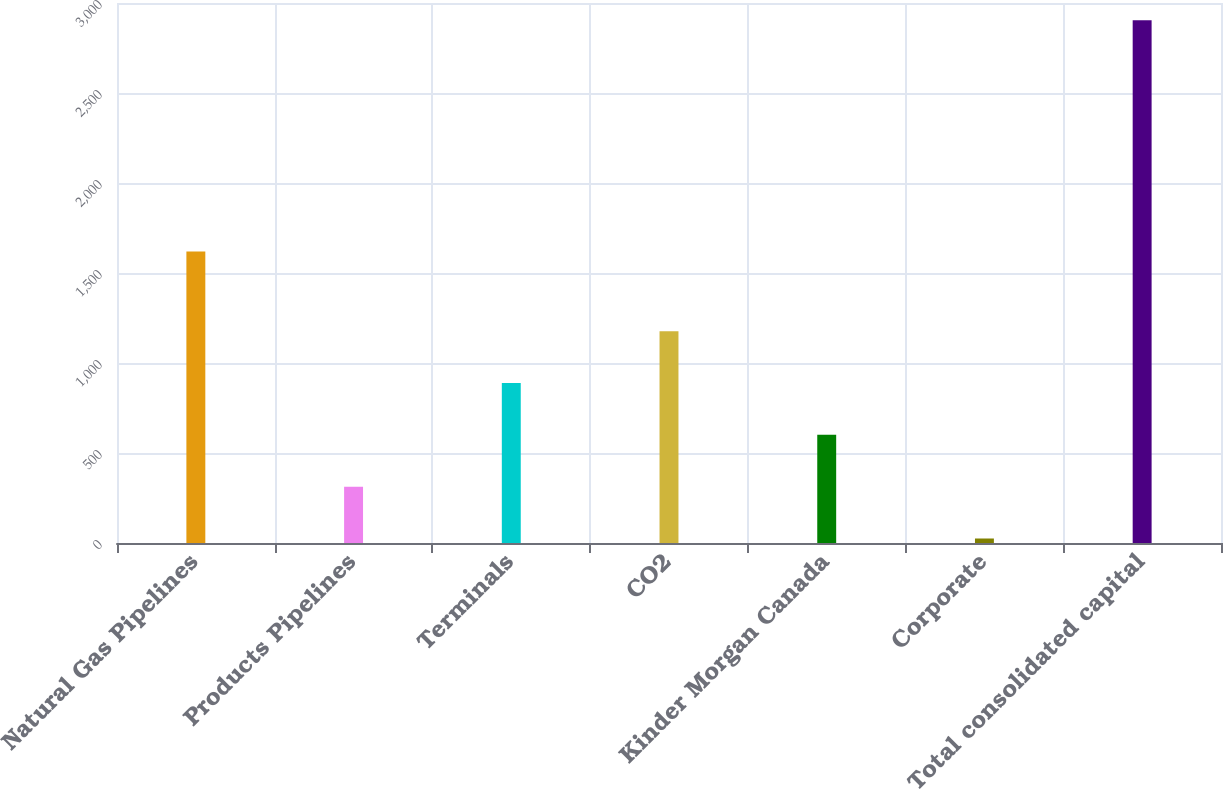Convert chart to OTSL. <chart><loc_0><loc_0><loc_500><loc_500><bar_chart><fcel>Natural Gas Pipelines<fcel>Products Pipelines<fcel>Terminals<fcel>CO2<fcel>Kinder Morgan Canada<fcel>Corporate<fcel>Total consolidated capital<nl><fcel>1620<fcel>312.9<fcel>888.7<fcel>1176.6<fcel>600.8<fcel>25<fcel>2904<nl></chart> 